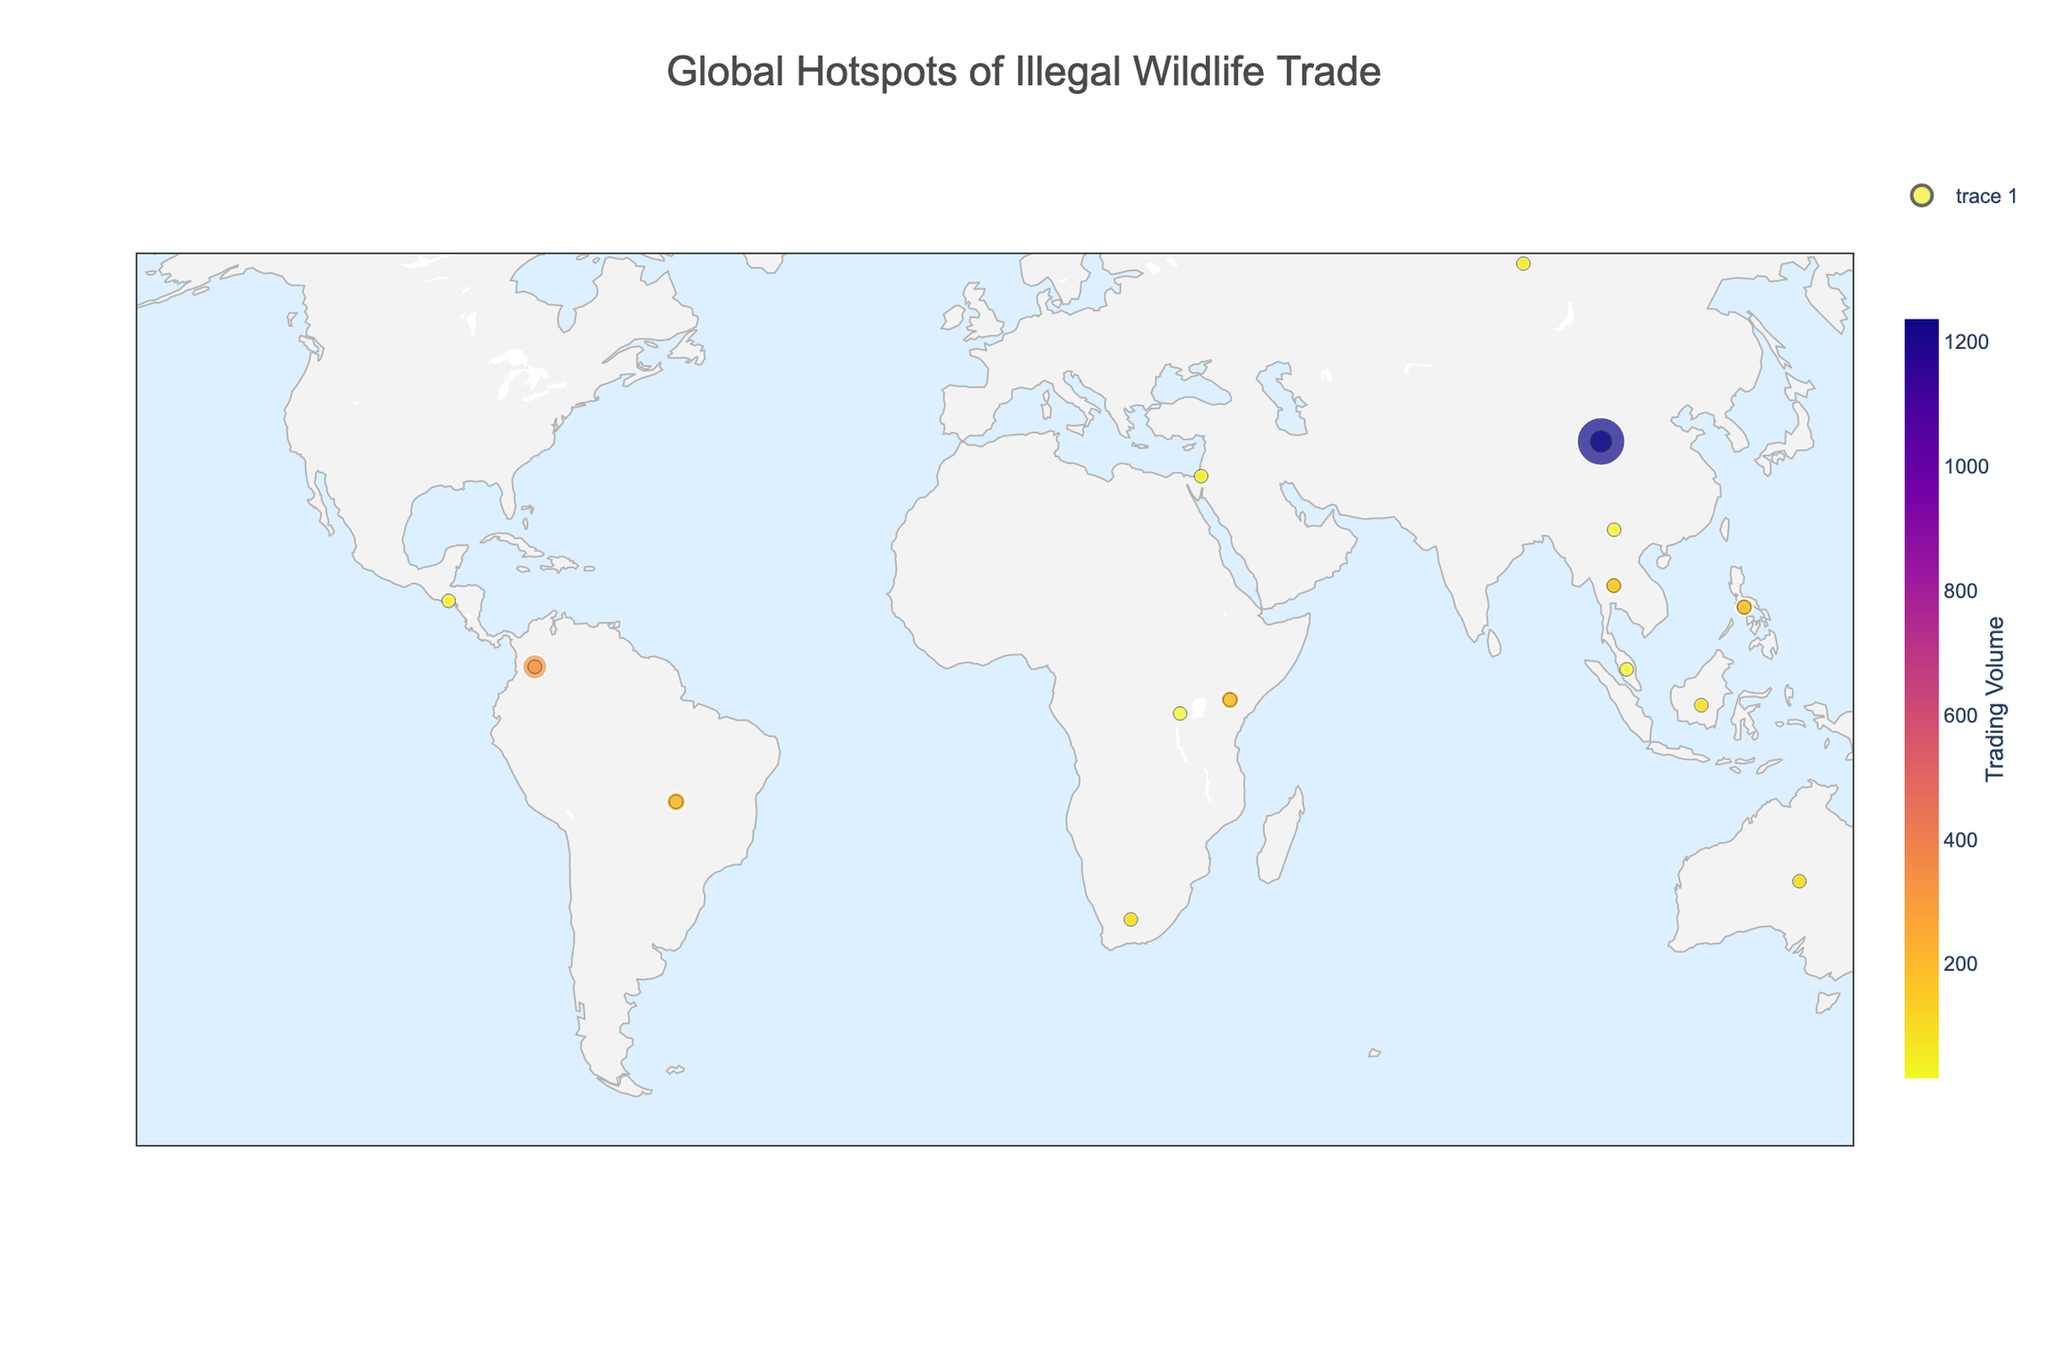What is the title of the figure? The title is typically placed at the top of the plot and describes what the plot represents.
Answer: Global Hotspots of Illegal Wildlife Trade What species has the highest trading volume? Look for the data point with the largest size on the plot, and hover over it to find the species associated with the largest trading volume.
Answer: Pangolin How many countries are represented in the figure? Count the number of unique data points or countries shown on the map.
Answer: 14 Which country is associated with the trade of Elephant ivory and what is the trading volume? Identify the data point associated with 'Elephant' and check the hover information to find the country and trading volume.
Answer: Thailand, 156 What is the most common trade type displayed in the plot? Analyze the trade type for each data point, and determine which one appears the most frequently.
Answer: Live Animals Rank the top three species by trading volume. Compare the sizes of the data points and check the hover information to rank the top three species.
Answer: Pangolin, Poison Dart Frog, Scarlet Macaw Which species is traded for body parts and what are their trading volumes? Look for data points associated with the trade type 'Body Parts' and check the species and trading volumes shown in the hover information.
Answer: Jaguar, 42 and Tiger, 31 What is the median trading volume of all species displayed in the plot? Arrange the trading volumes in ascending order and find the middle value.
Answer: 89 Which species traded in Colombia and Kenya, and how do their trading volumes compare? Identify data points for Colombia and Kenya, check the hover information for the species and trading volumes, and compare them.
Answer: Colombia: Poison Dart Frog, 324; Kenya: African Grey Parrot, 189. Poison Dart Frog has a higher trading volume Which continents have hotspots of illegal wildlife trade represented in the figure? Observe the geographic spread of data points on the map and identify the continents where they are located.
Answer: Asia, Africa, North America, South America, Australia 